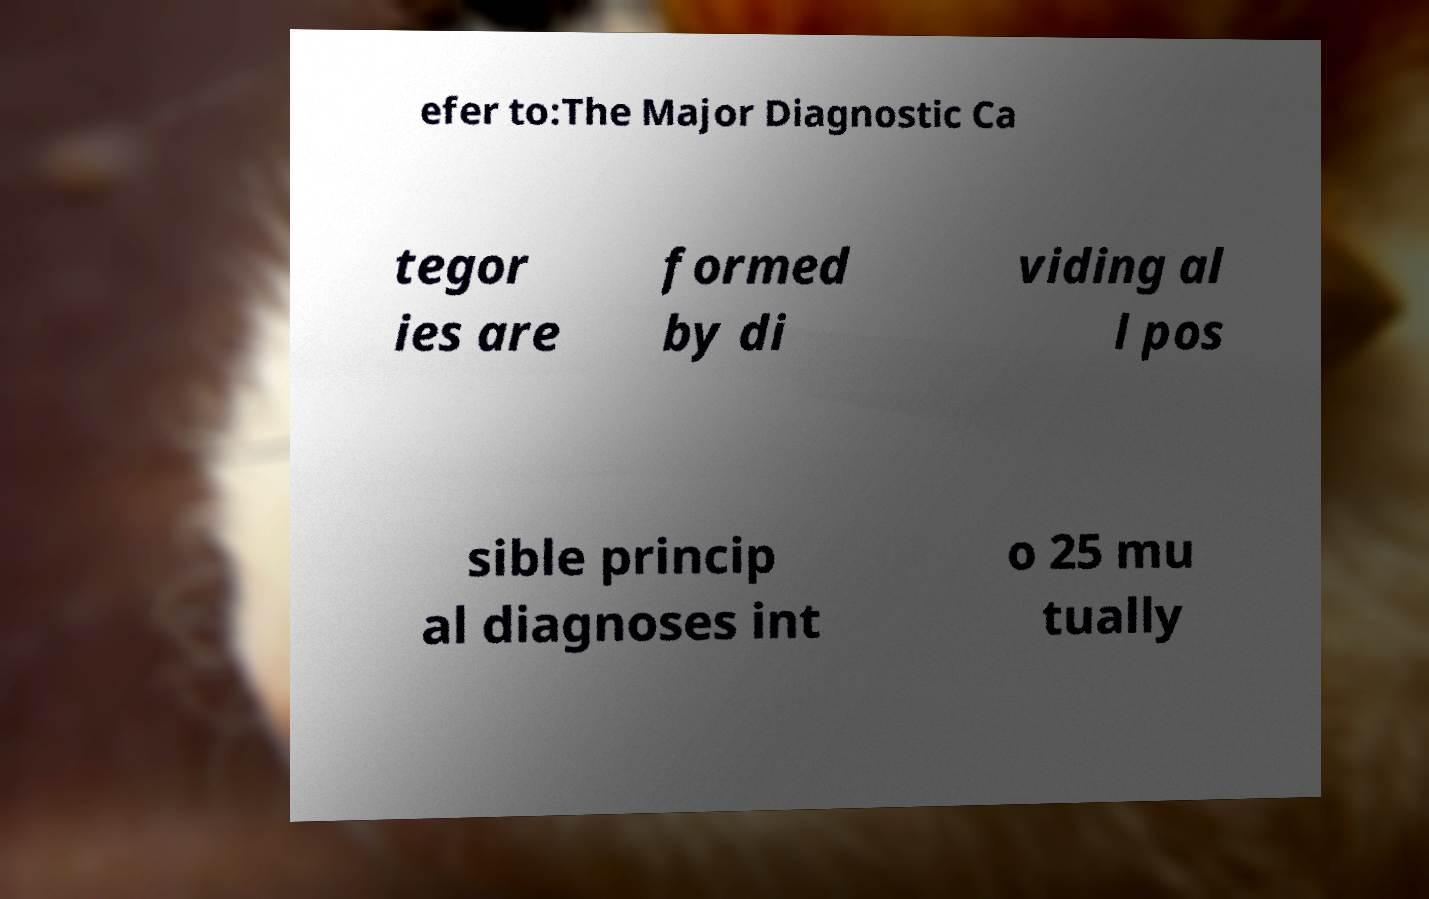Can you read and provide the text displayed in the image?This photo seems to have some interesting text. Can you extract and type it out for me? efer to:The Major Diagnostic Ca tegor ies are formed by di viding al l pos sible princip al diagnoses int o 25 mu tually 